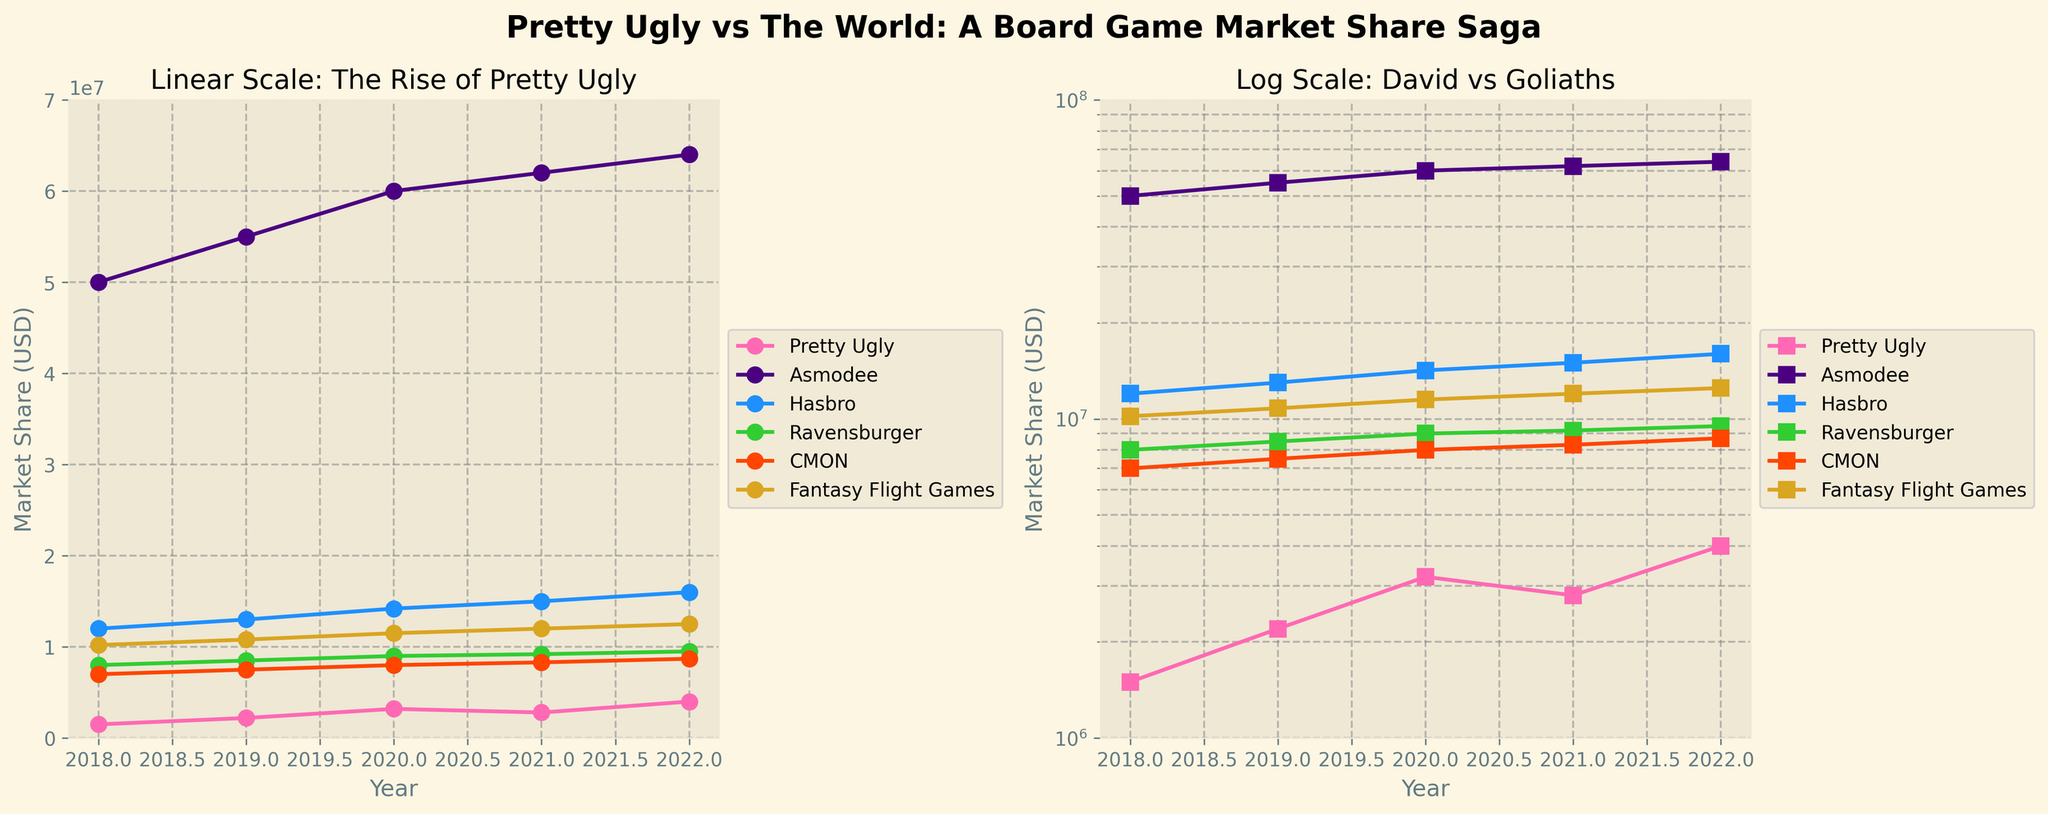What is the title of the figure? The title of the figure is centered at the top of the plot and reads "Pretty Ugly vs The World: A Board Game Market Share Saga".
Answer: Pretty Ugly vs The World: A Board Game Market Share Saga What are the colors used for Pretty Ugly and Asmodee in the plots? The color used for Pretty Ugly is a bright pink color, and Asmodee is represented by a dark purple color. These colors are consistent across both the linear and log scale plots.
Answer: Pink for Pretty Ugly and Purple for Asmodee Which publisher has the highest market share in 2022 in the log scale plot? In the log scale plot, the publisher with the highest market share in 2022 can be observed as the one with the highest point on the vertical axis. Asmodee is at the highest position with a market share of approximately 64,000,000 USD.
Answer: Asmodee Across all years, how does Pretty Ugly's market share growth compare to Hasbro's in the linear scale plot? Comparing the slopes of the lines in the linear scale plot, Pretty Ugly's line has a steeper upward trajectory, indicating a faster growth rate in market share compared to Hasbro's more gradual upward slope.
Answer: Pretty Ugly's growth is steeper What is the market share difference between Pretty Ugly and CMON in 2020 on the linear scale plot? On the linear scale plot, Pretty Ugly’s market share is around 3,200,000 USD and CMON's market share is around 8,000,000 USD in 2020. The difference can be calculated as 8,000,000 - 3,200,000 = 4,800,000 USD.
Answer: 4,800,000 USD How does the grid appearance differ between the linear and log scale plots? In both plots, grid lines are present; however, the log scale plot has more pronounced grid lines, useful for interpreting the logarithmic differences in data. This helps in more accurately gauging smaller differences in larger values.
Answer: Log scale has more pronounced grid lines In the linear scale plot, which publisher shows the least variation in market share from 2018 to 2022? On visually inspecting the linear scale plot, Ravensburger shows a relatively flat line indicating the least variation in market share between 2018 and 2022.
Answer: Ravensburger How does Pretty Ugly's market share in 2019 compare to Fantasy Flight Games in the same year on the linear scale plot? In 2019, Pretty Ugly's market share appears to be around 2,200,000 USD while Fantasy Flight Games is approximately 10,800,000 USD. Fantasy Flight Games’ market share is significantly higher than Pretty Ugly’s in that year.
Answer: Fantasy Flight Games is higher Why is a log scale useful in this figure for comparing publishers? A log scale is useful for comparing publishers with widely varying market shares because it compresses the scale of larger values and expands the scale for smaller values, making it easier to visualize proportional differences and see trends more clearly among all publishers.
Answer: Useful for wide variance in market shares 